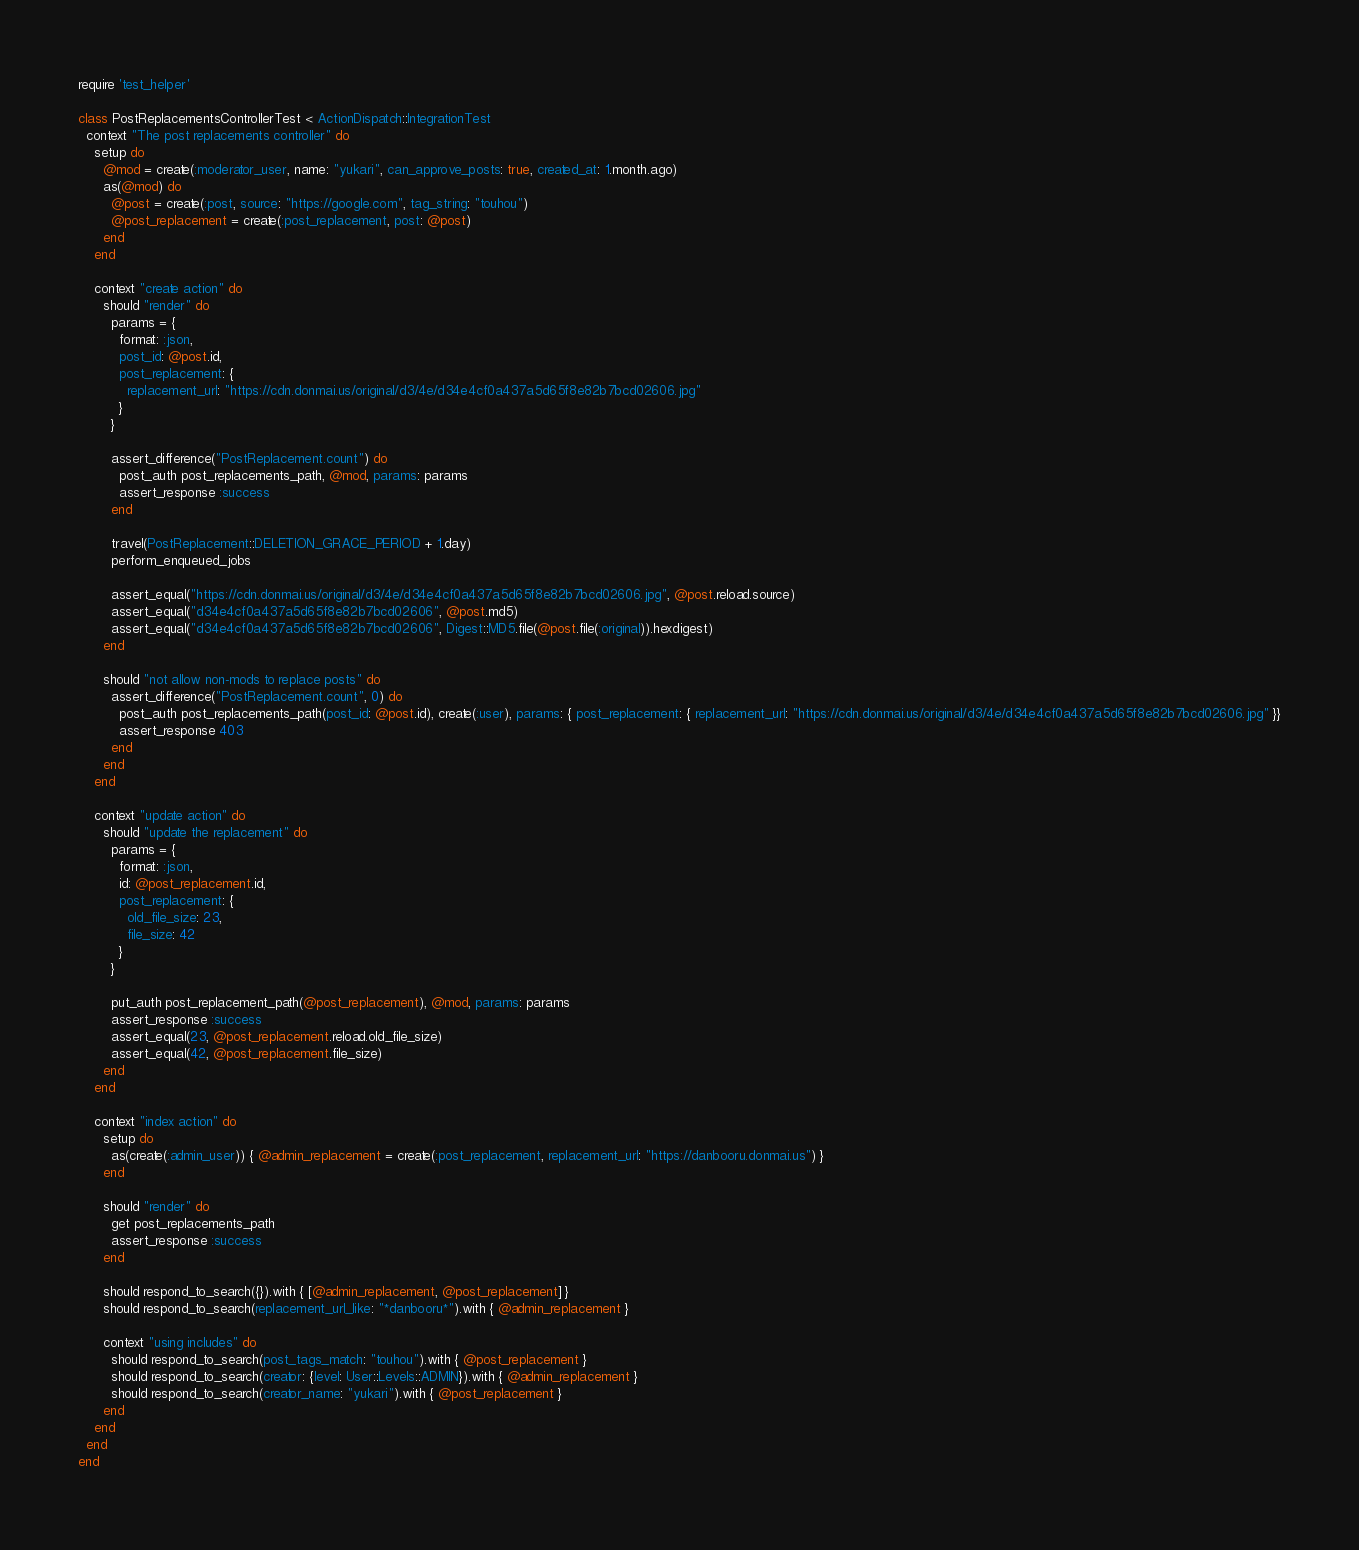<code> <loc_0><loc_0><loc_500><loc_500><_Ruby_>require 'test_helper'

class PostReplacementsControllerTest < ActionDispatch::IntegrationTest
  context "The post replacements controller" do
    setup do
      @mod = create(:moderator_user, name: "yukari", can_approve_posts: true, created_at: 1.month.ago)
      as(@mod) do
        @post = create(:post, source: "https://google.com", tag_string: "touhou")
        @post_replacement = create(:post_replacement, post: @post)
      end
    end

    context "create action" do
      should "render" do
        params = {
          format: :json,
          post_id: @post.id,
          post_replacement: {
            replacement_url: "https://cdn.donmai.us/original/d3/4e/d34e4cf0a437a5d65f8e82b7bcd02606.jpg"
          }
        }

        assert_difference("PostReplacement.count") do
          post_auth post_replacements_path, @mod, params: params
          assert_response :success
        end

        travel(PostReplacement::DELETION_GRACE_PERIOD + 1.day)
        perform_enqueued_jobs

        assert_equal("https://cdn.donmai.us/original/d3/4e/d34e4cf0a437a5d65f8e82b7bcd02606.jpg", @post.reload.source)
        assert_equal("d34e4cf0a437a5d65f8e82b7bcd02606", @post.md5)
        assert_equal("d34e4cf0a437a5d65f8e82b7bcd02606", Digest::MD5.file(@post.file(:original)).hexdigest)
      end

      should "not allow non-mods to replace posts" do
        assert_difference("PostReplacement.count", 0) do
          post_auth post_replacements_path(post_id: @post.id), create(:user), params: { post_replacement: { replacement_url: "https://cdn.donmai.us/original/d3/4e/d34e4cf0a437a5d65f8e82b7bcd02606.jpg" }}
          assert_response 403
        end
      end
    end

    context "update action" do
      should "update the replacement" do
        params = {
          format: :json,
          id: @post_replacement.id,
          post_replacement: {
            old_file_size: 23,
            file_size: 42
          }
        }

        put_auth post_replacement_path(@post_replacement), @mod, params: params
        assert_response :success
        assert_equal(23, @post_replacement.reload.old_file_size)
        assert_equal(42, @post_replacement.file_size)
      end
    end

    context "index action" do
      setup do
        as(create(:admin_user)) { @admin_replacement = create(:post_replacement, replacement_url: "https://danbooru.donmai.us") }
      end

      should "render" do
        get post_replacements_path
        assert_response :success
      end

      should respond_to_search({}).with { [@admin_replacement, @post_replacement] }
      should respond_to_search(replacement_url_like: "*danbooru*").with { @admin_replacement }

      context "using includes" do
        should respond_to_search(post_tags_match: "touhou").with { @post_replacement }
        should respond_to_search(creator: {level: User::Levels::ADMIN}).with { @admin_replacement }
        should respond_to_search(creator_name: "yukari").with { @post_replacement }
      end
    end
  end
end
</code> 